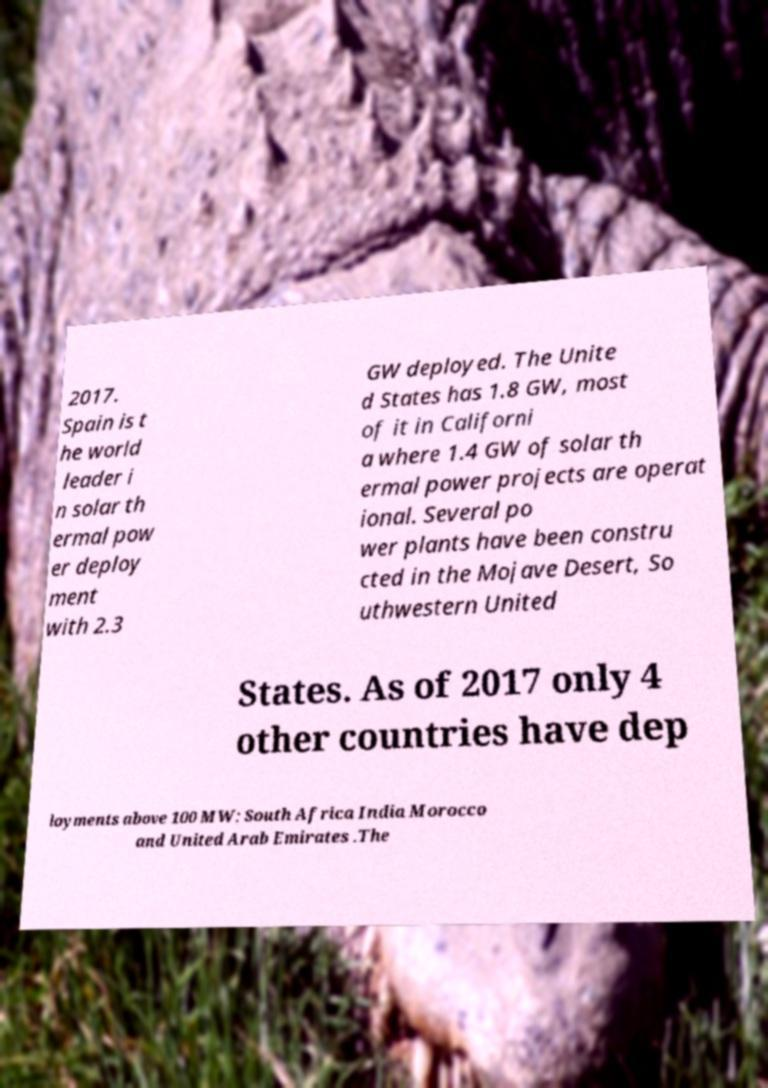Can you read and provide the text displayed in the image?This photo seems to have some interesting text. Can you extract and type it out for me? 2017. Spain is t he world leader i n solar th ermal pow er deploy ment with 2.3 GW deployed. The Unite d States has 1.8 GW, most of it in Californi a where 1.4 GW of solar th ermal power projects are operat ional. Several po wer plants have been constru cted in the Mojave Desert, So uthwestern United States. As of 2017 only 4 other countries have dep loyments above 100 MW: South Africa India Morocco and United Arab Emirates .The 